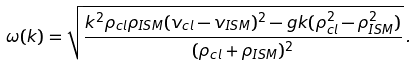Convert formula to latex. <formula><loc_0><loc_0><loc_500><loc_500>\omega ( k ) = \sqrt { \frac { k ^ { 2 } \rho _ { c l } \rho _ { I S M } ( v _ { c l } - v _ { I S M } ) ^ { 2 } - g k ( \rho _ { c l } ^ { 2 } - \rho _ { I S M } ^ { 2 } ) } { ( \rho _ { c l } + \rho _ { I S M } ) ^ { 2 } } } \, .</formula> 